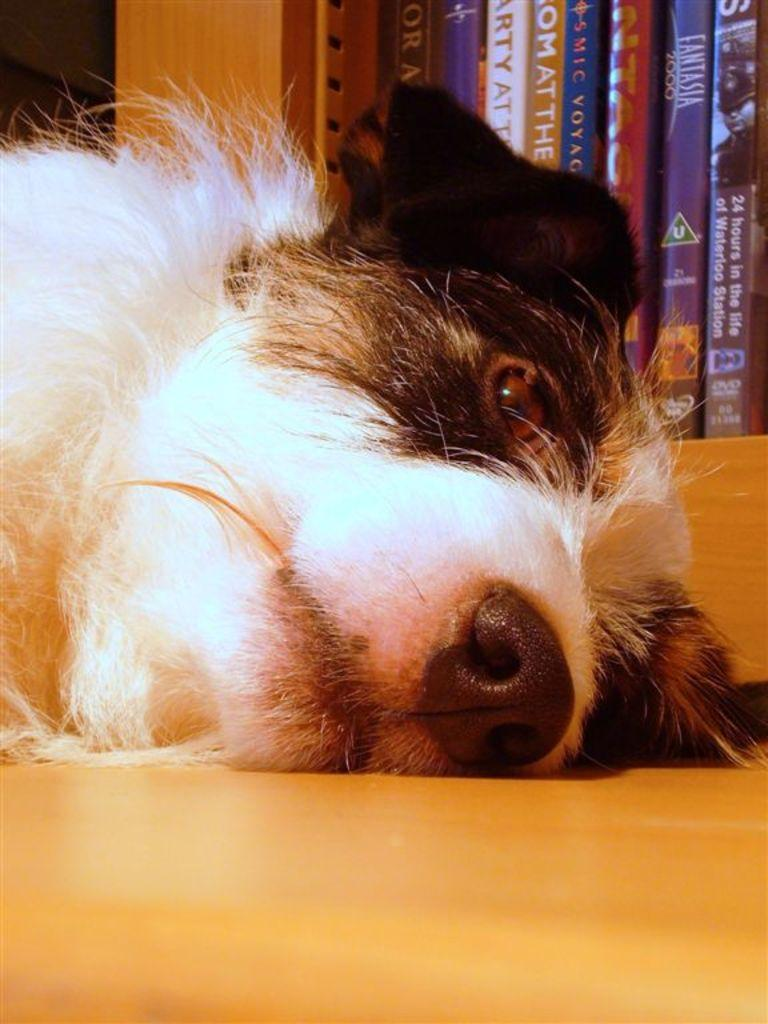What type of animal is present in the image? There is a dog in the image. What is the dog doing in the image? The dog is laying on the floor. What else can be seen in the image besides the dog? There is a rack with many books in the image. What type of paste is the dog sniffing in the image? There is no paste present in the image, and the dog is not shown sniffing anything. What type of operation is the dog undergoing in the image? There is no operation present in the image, and the dog is simply laying on the floor. 